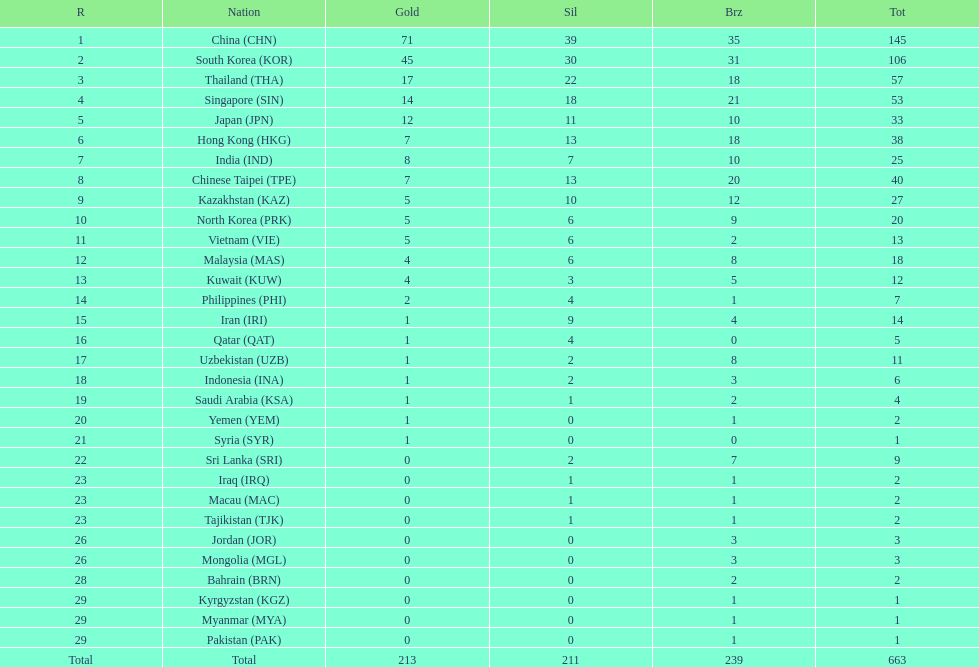How many countries have at least 10 gold medals in the asian youth games? 5. 